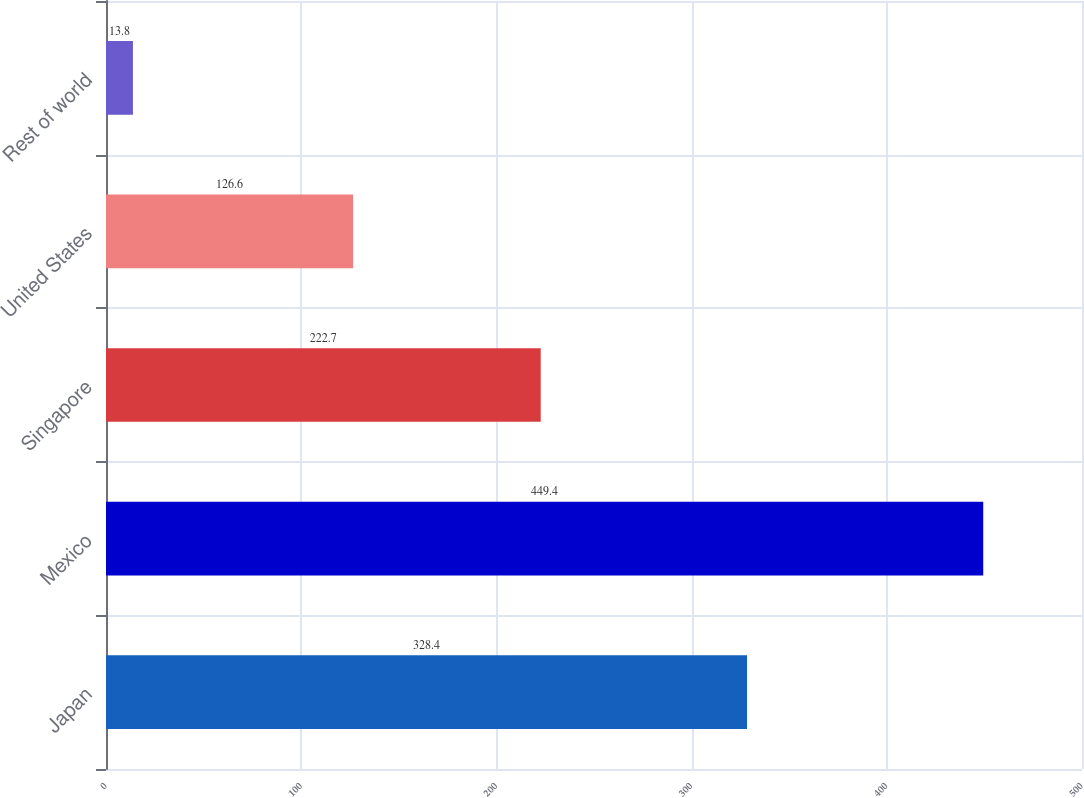<chart> <loc_0><loc_0><loc_500><loc_500><bar_chart><fcel>Japan<fcel>Mexico<fcel>Singapore<fcel>United States<fcel>Rest of world<nl><fcel>328.4<fcel>449.4<fcel>222.7<fcel>126.6<fcel>13.8<nl></chart> 